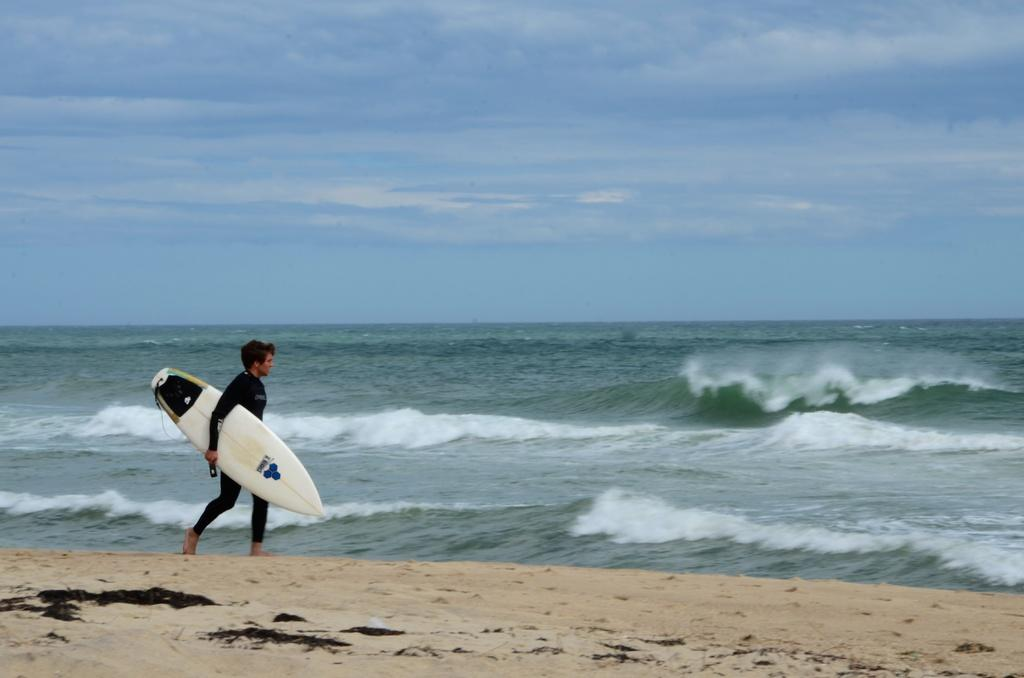What is the main subject of the image? There is a person in the image. What is the person doing in the image? The person is walking. What object is the person holding in the image? The person is holding a skateboard. What can be seen in the background of the image? There is a sea and the sky visible in the background of the image. What type of stamp can be seen on the person's forehead in the image? There is no stamp visible on the person's forehead in the image. How does the skateboard affect the condition of the sea in the image? The skateboard is not interacting with the sea in the image, so it does not affect the condition of the sea. 